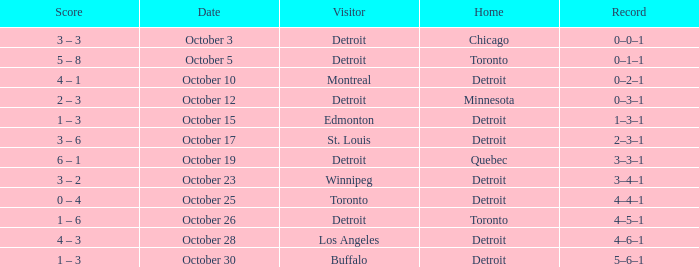Name the home with toronto visiting Detroit. 